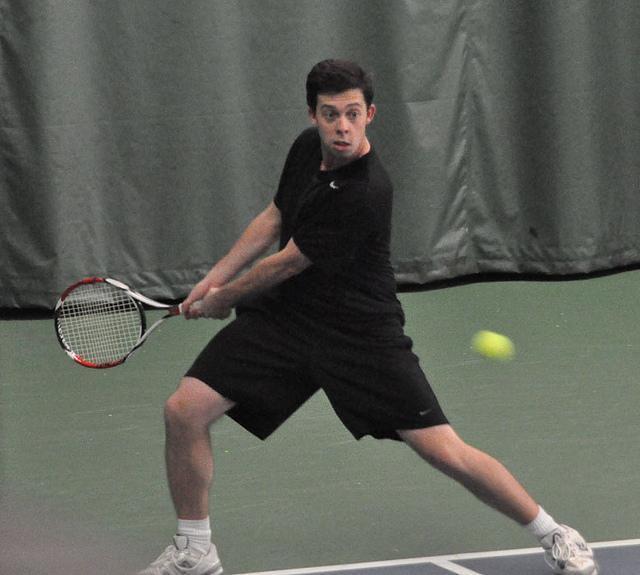How many hands are on the racket?
Give a very brief answer. 2. 